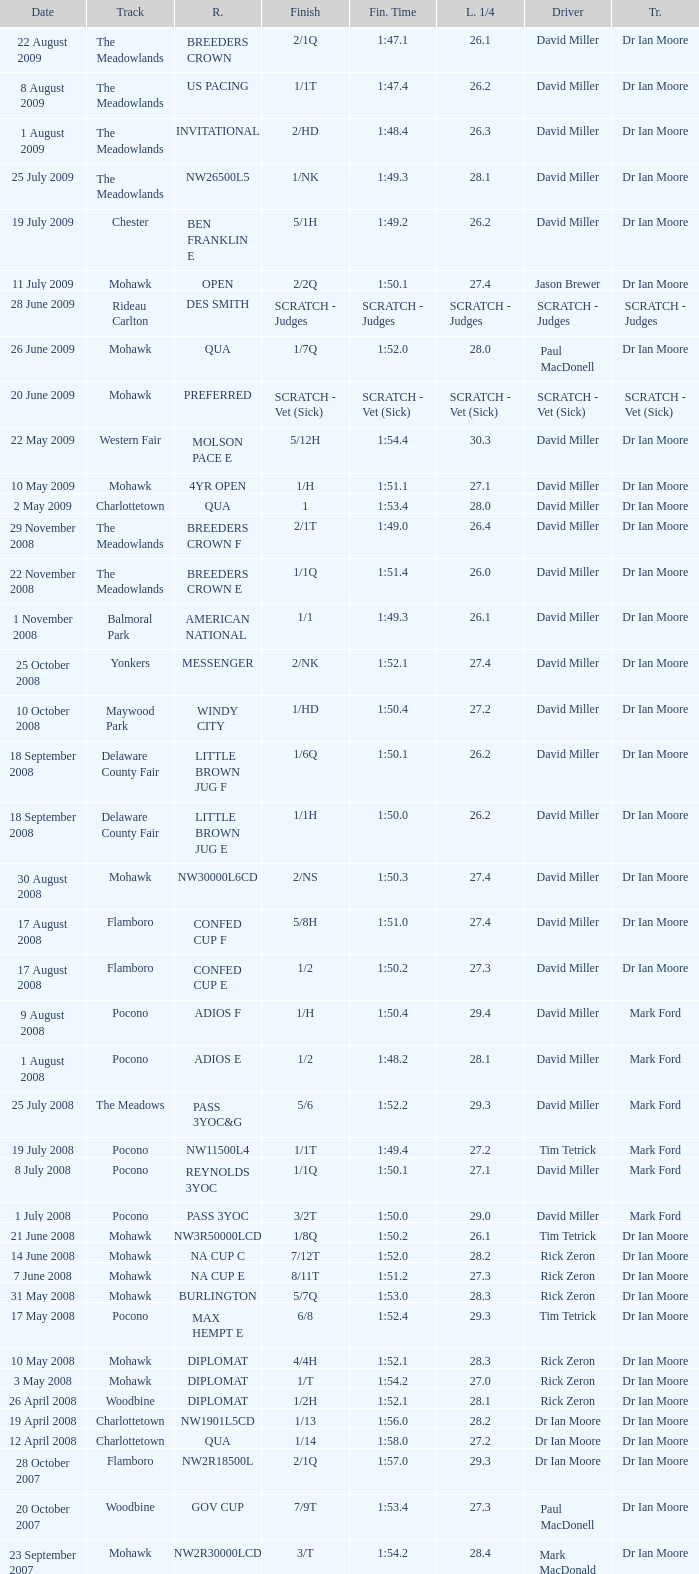What is the last 1/4 for the QUA race with a finishing time of 2:03.1? 29.2. Parse the full table. {'header': ['Date', 'Track', 'R.', 'Finish', 'Fin. Time', 'L. 1/4', 'Driver', 'Tr.'], 'rows': [['22 August 2009', 'The Meadowlands', 'BREEDERS CROWN', '2/1Q', '1:47.1', '26.1', 'David Miller', 'Dr Ian Moore'], ['8 August 2009', 'The Meadowlands', 'US PACING', '1/1T', '1:47.4', '26.2', 'David Miller', 'Dr Ian Moore'], ['1 August 2009', 'The Meadowlands', 'INVITATIONAL', '2/HD', '1:48.4', '26.3', 'David Miller', 'Dr Ian Moore'], ['25 July 2009', 'The Meadowlands', 'NW26500L5', '1/NK', '1:49.3', '28.1', 'David Miller', 'Dr Ian Moore'], ['19 July 2009', 'Chester', 'BEN FRANKLIN E', '5/1H', '1:49.2', '26.2', 'David Miller', 'Dr Ian Moore'], ['11 July 2009', 'Mohawk', 'OPEN', '2/2Q', '1:50.1', '27.4', 'Jason Brewer', 'Dr Ian Moore'], ['28 June 2009', 'Rideau Carlton', 'DES SMITH', 'SCRATCH - Judges', 'SCRATCH - Judges', 'SCRATCH - Judges', 'SCRATCH - Judges', 'SCRATCH - Judges'], ['26 June 2009', 'Mohawk', 'QUA', '1/7Q', '1:52.0', '28.0', 'Paul MacDonell', 'Dr Ian Moore'], ['20 June 2009', 'Mohawk', 'PREFERRED', 'SCRATCH - Vet (Sick)', 'SCRATCH - Vet (Sick)', 'SCRATCH - Vet (Sick)', 'SCRATCH - Vet (Sick)', 'SCRATCH - Vet (Sick)'], ['22 May 2009', 'Western Fair', 'MOLSON PACE E', '5/12H', '1:54.4', '30.3', 'David Miller', 'Dr Ian Moore'], ['10 May 2009', 'Mohawk', '4YR OPEN', '1/H', '1:51.1', '27.1', 'David Miller', 'Dr Ian Moore'], ['2 May 2009', 'Charlottetown', 'QUA', '1', '1:53.4', '28.0', 'David Miller', 'Dr Ian Moore'], ['29 November 2008', 'The Meadowlands', 'BREEDERS CROWN F', '2/1T', '1:49.0', '26.4', 'David Miller', 'Dr Ian Moore'], ['22 November 2008', 'The Meadowlands', 'BREEDERS CROWN E', '1/1Q', '1:51.4', '26.0', 'David Miller', 'Dr Ian Moore'], ['1 November 2008', 'Balmoral Park', 'AMERICAN NATIONAL', '1/1', '1:49.3', '26.1', 'David Miller', 'Dr Ian Moore'], ['25 October 2008', 'Yonkers', 'MESSENGER', '2/NK', '1:52.1', '27.4', 'David Miller', 'Dr Ian Moore'], ['10 October 2008', 'Maywood Park', 'WINDY CITY', '1/HD', '1:50.4', '27.2', 'David Miller', 'Dr Ian Moore'], ['18 September 2008', 'Delaware County Fair', 'LITTLE BROWN JUG F', '1/6Q', '1:50.1', '26.2', 'David Miller', 'Dr Ian Moore'], ['18 September 2008', 'Delaware County Fair', 'LITTLE BROWN JUG E', '1/1H', '1:50.0', '26.2', 'David Miller', 'Dr Ian Moore'], ['30 August 2008', 'Mohawk', 'NW30000L6CD', '2/NS', '1:50.3', '27.4', 'David Miller', 'Dr Ian Moore'], ['17 August 2008', 'Flamboro', 'CONFED CUP F', '5/8H', '1:51.0', '27.4', 'David Miller', 'Dr Ian Moore'], ['17 August 2008', 'Flamboro', 'CONFED CUP E', '1/2', '1:50.2', '27.3', 'David Miller', 'Dr Ian Moore'], ['9 August 2008', 'Pocono', 'ADIOS F', '1/H', '1:50.4', '29.4', 'David Miller', 'Mark Ford'], ['1 August 2008', 'Pocono', 'ADIOS E', '1/2', '1:48.2', '28.1', 'David Miller', 'Mark Ford'], ['25 July 2008', 'The Meadows', 'PASS 3YOC&G', '5/6', '1:52.2', '29.3', 'David Miller', 'Mark Ford'], ['19 July 2008', 'Pocono', 'NW11500L4', '1/1T', '1:49.4', '27.2', 'Tim Tetrick', 'Mark Ford'], ['8 July 2008', 'Pocono', 'REYNOLDS 3YOC', '1/1Q', '1:50.1', '27.1', 'David Miller', 'Mark Ford'], ['1 July 2008', 'Pocono', 'PASS 3YOC', '3/2T', '1:50.0', '29.0', 'David Miller', 'Mark Ford'], ['21 June 2008', 'Mohawk', 'NW3R50000LCD', '1/8Q', '1:50.2', '26.1', 'Tim Tetrick', 'Dr Ian Moore'], ['14 June 2008', 'Mohawk', 'NA CUP C', '7/12T', '1:52.0', '28.2', 'Rick Zeron', 'Dr Ian Moore'], ['7 June 2008', 'Mohawk', 'NA CUP E', '8/11T', '1:51.2', '27.3', 'Rick Zeron', 'Dr Ian Moore'], ['31 May 2008', 'Mohawk', 'BURLINGTON', '5/7Q', '1:53.0', '28.3', 'Rick Zeron', 'Dr Ian Moore'], ['17 May 2008', 'Pocono', 'MAX HEMPT E', '6/8', '1:52.4', '29.3', 'Tim Tetrick', 'Dr Ian Moore'], ['10 May 2008', 'Mohawk', 'DIPLOMAT', '4/4H', '1:52.1', '28.3', 'Rick Zeron', 'Dr Ian Moore'], ['3 May 2008', 'Mohawk', 'DIPLOMAT', '1/T', '1:54.2', '27.0', 'Rick Zeron', 'Dr Ian Moore'], ['26 April 2008', 'Woodbine', 'DIPLOMAT', '1/2H', '1:52.1', '28.1', 'Rick Zeron', 'Dr Ian Moore'], ['19 April 2008', 'Charlottetown', 'NW1901L5CD', '1/13', '1:56.0', '28.2', 'Dr Ian Moore', 'Dr Ian Moore'], ['12 April 2008', 'Charlottetown', 'QUA', '1/14', '1:58.0', '27.2', 'Dr Ian Moore', 'Dr Ian Moore'], ['28 October 2007', 'Flamboro', 'NW2R18500L', '2/1Q', '1:57.0', '29.3', 'Dr Ian Moore', 'Dr Ian Moore'], ['20 October 2007', 'Woodbine', 'GOV CUP', '7/9T', '1:53.4', '27.3', 'Paul MacDonell', 'Dr Ian Moore'], ['23 September 2007', 'Mohawk', 'NW2R30000LCD', '3/T', '1:54.2', '28.4', 'Mark MacDonald', 'Dr Ian Moore'], ['15 September 2007', 'Mohawk', 'NASAGAWEYA', '8/12T', '1:55.2', '30.3', 'Mark MacDonald', 'Dr Ian Moore'], ['1 September 2007', 'Mohawk', 'METRO F', '6/9T', '1:51.3', '28.2', 'Mark MacDonald', 'Dr Ian Moore'], ['25 August 2007', 'Mohawk', 'METRO E', '3/4', '1:53.0', '28.1', 'Mark MacDonald', 'Dr Ian Moore'], ['19 August 2007', 'Mohawk', 'NW2R22000LCD', '3/1', '1:53.1', '27.2', 'Paul MacDonell', 'Dr Ian Moore'], ['6 August 2007', 'Mohawk', 'DREAM MAKER', '4/2Q', '1:54.1', '28.1', 'Paul MacDonell', 'Dr Ian Moore'], ['30 July 2007', 'Mohawk', 'DREAM MAKER', '2/1T', '1:53.4', '30.0', 'Dr Ian Moore', 'Dr Ian Moore'], ['23 July 2007', 'Mohawk', 'DREAM MAKER', '2/Q', '1:54.0', '27.4', 'Paul MacDonell', 'Dr Ian Moore'], ['15 July 2007', 'Mohawk', '2YR-C-COND', '1/H', '1:57.2', '27.3', 'Dr Ian Moore', 'Dr Ian Moore'], ['30 June 2007', 'Charlottetown', 'NW2RLFTCD', '1/4H', '1:58.0', '28.1', 'Dr Ian Moore', 'Dr Ian Moore'], ['21 June 2007', 'Charlottetown', 'NW1RLFT', '1/4H', '2:02.3', '29.4', 'Dr Ian Moore', 'Dr Ian Moore'], ['14 June 2007', 'Charlottetown', 'QUA', '1/5H', '2:03.1', '29.2', 'Dr Ian Moore', 'Dr Ian Moore']]} 